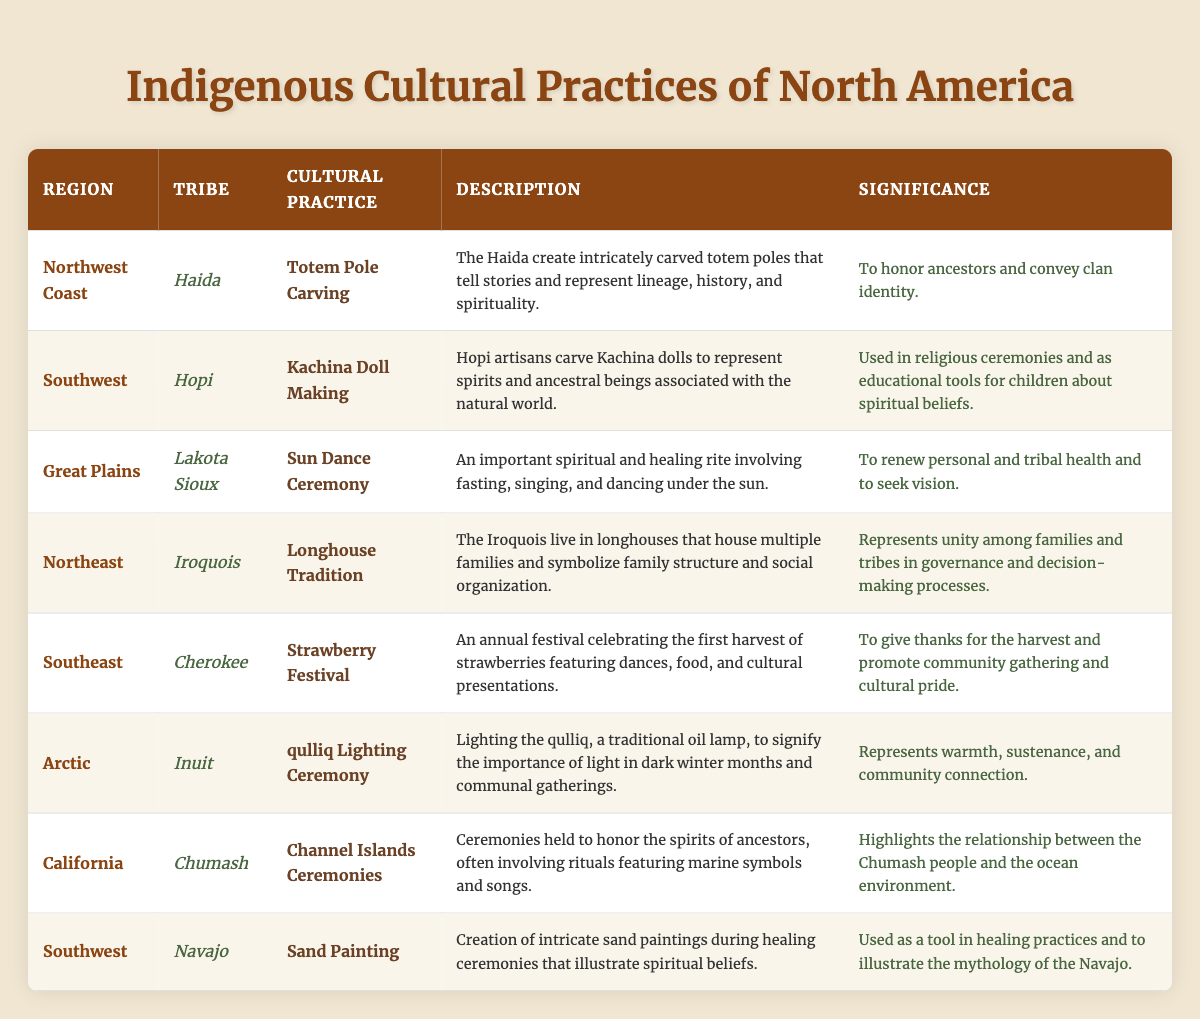What cultural practice is associated with the Haida tribe? The Haida tribe is featured in the "Northwest Coast" region and their cultural practice is "Totem Pole Carving." This is retrieved directly from the table under the corresponding columns for the tribe, region, and cultural practice.
Answer: Totem Pole Carving Which tribe participates in the Strawberry Festival? The Strawberry Festival is associated with the Cherokee tribe in the "Southeast" region. This can be found in the table by searching for the cultural practice "Strawberry Festival."
Answer: Cherokee Is the Sun Dance Ceremony significant for personal and tribal health? Yes, the significance of the Sun Dance Ceremony for the Lakota Sioux tribe is to renew personal and tribal health, which is explicitly stated in the significance column of the table.
Answer: Yes How many cultural practices listed are from the Southwest region? There are two cultural practices from the Southwest region: "Kachina Doll Making" by the Hopi tribe and "Sand Painting" by the Navajo tribe. This can be confirmed by counting the entries under the Southwest region in the table.
Answer: 2 Which cultural practice involves a traditional oil lamp in the Arctic region? The "qulliq Lighting Ceremony" is the cultural practice that involves a traditional oil lamp, specifically emphasizing its importance during dark winter months, as stated in the table.
Answer: qulliq Lighting Ceremony Does any tribe's cultural practice include elements related to marine symbols? Yes, the Chumash tribe holds "Channel Islands Ceremonies," which involve rituals featuring marine symbols, as described in the table.
Answer: Yes Which region has a cultural practice focused on family structure and social organization? The Northeast region has the "Longhouse Tradition" associated with the Iroquois tribe, which focuses on family structure and social organization, as indicated in the table.
Answer: Northeast What is the significance of the Kachina Doll Making practice? The significance of Kachina Doll Making is that it is used in religious ceremonies and as educational tools for children about spiritual beliefs, found in the significance column for the Hopi tribe's practice.
Answer: Used in religious ceremonies and education How does the significance of the Strawberry Festival enhance community connections? The significance of the Strawberry Festival includes giving thanks for the harvest and promoting community gathering and cultural pride; this content can be broken down into two parts of significance: gratitude and community interaction found in the table.
Answer: Cultural pride and community gathering 